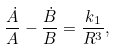Convert formula to latex. <formula><loc_0><loc_0><loc_500><loc_500>\frac { \dot { A } } { A } - \frac { \dot { B } } { B } = \frac { k _ { 1 } } { R ^ { 3 } } ,</formula> 